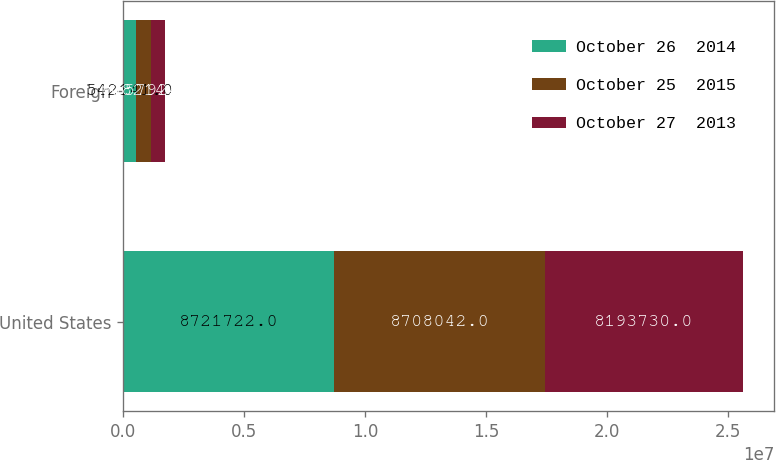<chart> <loc_0><loc_0><loc_500><loc_500><stacked_bar_chart><ecel><fcel>United States<fcel>Foreign<nl><fcel>October 26  2014<fcel>8.72172e+06<fcel>542141<nl><fcel>October 25  2015<fcel>8.70804e+06<fcel>608214<nl><fcel>October 27  2013<fcel>8.19373e+06<fcel>557924<nl></chart> 